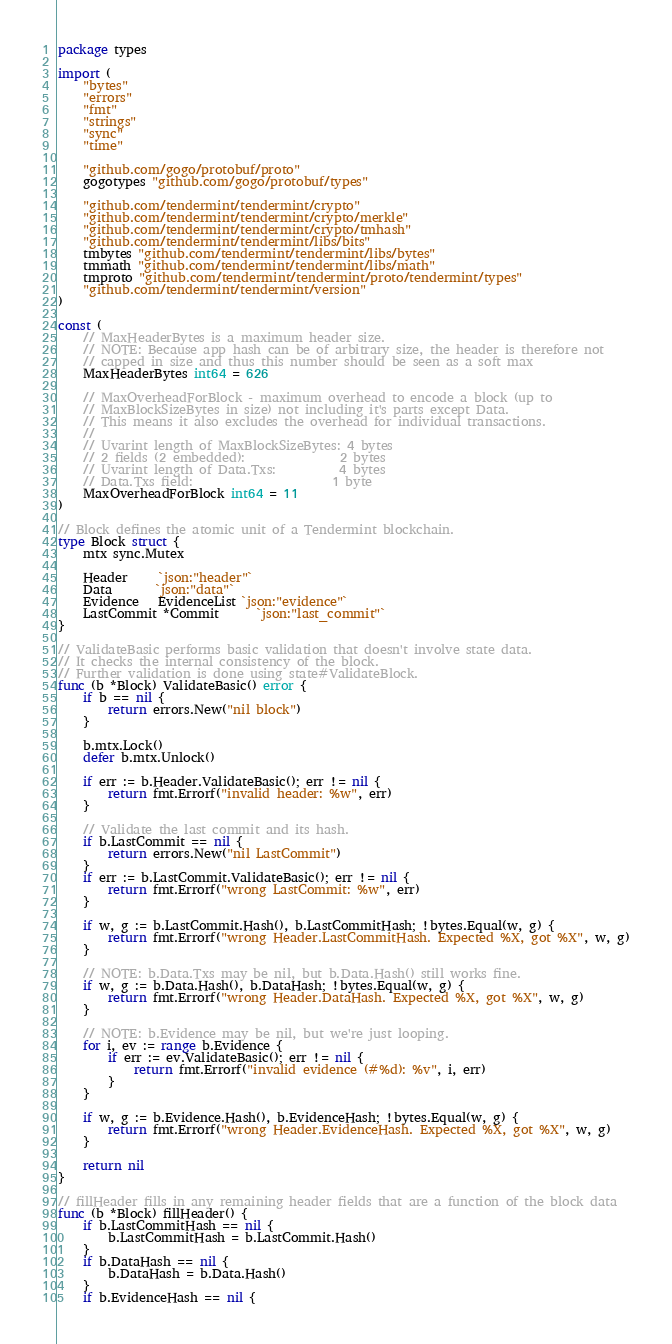<code> <loc_0><loc_0><loc_500><loc_500><_Go_>package types

import (
	"bytes"
	"errors"
	"fmt"
	"strings"
	"sync"
	"time"

	"github.com/gogo/protobuf/proto"
	gogotypes "github.com/gogo/protobuf/types"

	"github.com/tendermint/tendermint/crypto"
	"github.com/tendermint/tendermint/crypto/merkle"
	"github.com/tendermint/tendermint/crypto/tmhash"
	"github.com/tendermint/tendermint/libs/bits"
	tmbytes "github.com/tendermint/tendermint/libs/bytes"
	tmmath "github.com/tendermint/tendermint/libs/math"
	tmproto "github.com/tendermint/tendermint/proto/tendermint/types"
	"github.com/tendermint/tendermint/version"
)

const (
	// MaxHeaderBytes is a maximum header size.
	// NOTE: Because app hash can be of arbitrary size, the header is therefore not
	// capped in size and thus this number should be seen as a soft max
	MaxHeaderBytes int64 = 626

	// MaxOverheadForBlock - maximum overhead to encode a block (up to
	// MaxBlockSizeBytes in size) not including it's parts except Data.
	// This means it also excludes the overhead for individual transactions.
	//
	// Uvarint length of MaxBlockSizeBytes: 4 bytes
	// 2 fields (2 embedded):               2 bytes
	// Uvarint length of Data.Txs:          4 bytes
	// Data.Txs field:                      1 byte
	MaxOverheadForBlock int64 = 11
)

// Block defines the atomic unit of a Tendermint blockchain.
type Block struct {
	mtx sync.Mutex

	Header     `json:"header"`
	Data       `json:"data"`
	Evidence   EvidenceList `json:"evidence"`
	LastCommit *Commit      `json:"last_commit"`
}

// ValidateBasic performs basic validation that doesn't involve state data.
// It checks the internal consistency of the block.
// Further validation is done using state#ValidateBlock.
func (b *Block) ValidateBasic() error {
	if b == nil {
		return errors.New("nil block")
	}

	b.mtx.Lock()
	defer b.mtx.Unlock()

	if err := b.Header.ValidateBasic(); err != nil {
		return fmt.Errorf("invalid header: %w", err)
	}

	// Validate the last commit and its hash.
	if b.LastCommit == nil {
		return errors.New("nil LastCommit")
	}
	if err := b.LastCommit.ValidateBasic(); err != nil {
		return fmt.Errorf("wrong LastCommit: %w", err)
	}

	if w, g := b.LastCommit.Hash(), b.LastCommitHash; !bytes.Equal(w, g) {
		return fmt.Errorf("wrong Header.LastCommitHash. Expected %X, got %X", w, g)
	}

	// NOTE: b.Data.Txs may be nil, but b.Data.Hash() still works fine.
	if w, g := b.Data.Hash(), b.DataHash; !bytes.Equal(w, g) {
		return fmt.Errorf("wrong Header.DataHash. Expected %X, got %X", w, g)
	}

	// NOTE: b.Evidence may be nil, but we're just looping.
	for i, ev := range b.Evidence {
		if err := ev.ValidateBasic(); err != nil {
			return fmt.Errorf("invalid evidence (#%d): %v", i, err)
		}
	}

	if w, g := b.Evidence.Hash(), b.EvidenceHash; !bytes.Equal(w, g) {
		return fmt.Errorf("wrong Header.EvidenceHash. Expected %X, got %X", w, g)
	}

	return nil
}

// fillHeader fills in any remaining header fields that are a function of the block data
func (b *Block) fillHeader() {
	if b.LastCommitHash == nil {
		b.LastCommitHash = b.LastCommit.Hash()
	}
	if b.DataHash == nil {
		b.DataHash = b.Data.Hash()
	}
	if b.EvidenceHash == nil {</code> 